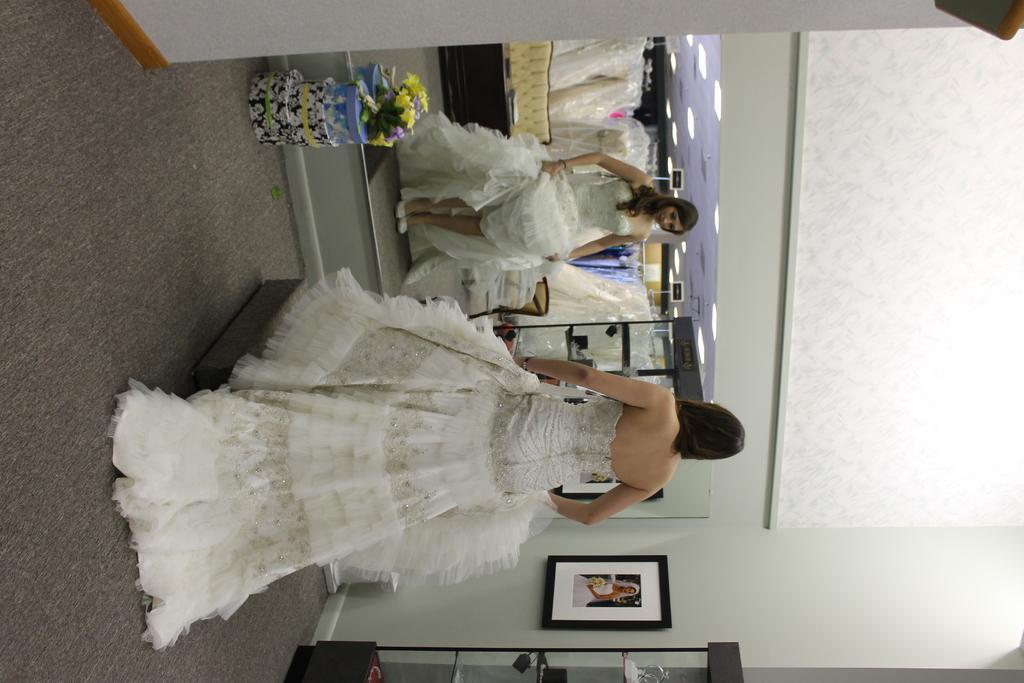How would you summarize this image in a sentence or two? In the image is an inverted image. In the image a lady wearing white gown is standing in front of a mirror. In the mirror there is reflection of the lady and the background of the room. On the ceiling there are lights. Here there is a photo frame. This is a cupboard. This is a gift box with a bouquet. In the background there is sofa and few more dresses are there. 